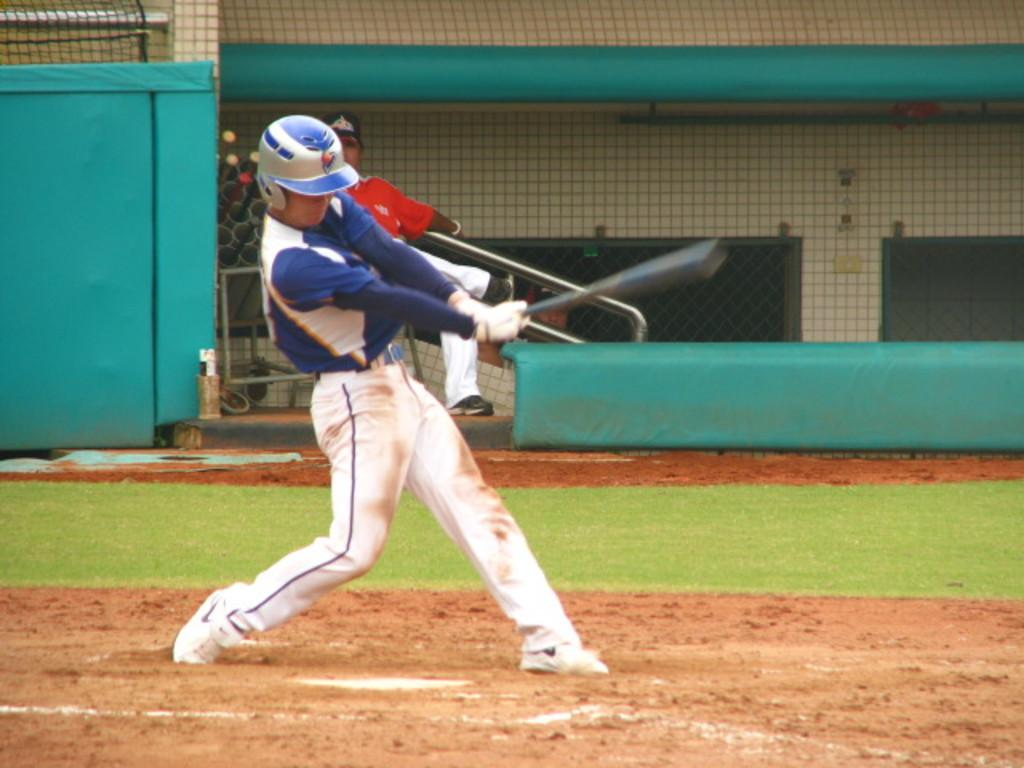What is the person in the image doing? There is a person playing on the ground in the image. What type of surface is the person playing on? There is grass in the image, which is the surface the person is playing on. What can be seen in the background of the image? There is a mesh and a wall visible in the image. How many apples are being used as toys by the person in the image? There is no mention of apples in the image; the person is playing on the grass. What type of ice can be seen melting on the mesh in the image? There is no ice present in the image; the mesh is a separate element in the background. 